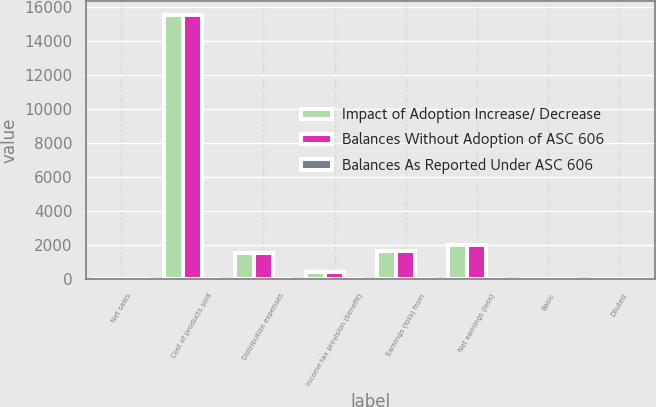<chart> <loc_0><loc_0><loc_500><loc_500><stacked_bar_chart><ecel><fcel>Net sales<fcel>Cost of products sold<fcel>Distribution expenses<fcel>Income tax provision (benefit)<fcel>Earnings (loss) from<fcel>Net earnings (loss)<fcel>Basic<fcel>Diluted<nl><fcel>Impact of Adoption Increase/ Decrease<fcel>26<fcel>15555<fcel>1567<fcel>445<fcel>1672<fcel>2017<fcel>4.91<fcel>4.85<nl><fcel>Balances Without Adoption of ASC 606<fcel>26<fcel>15535<fcel>1563<fcel>443<fcel>1666<fcel>2011<fcel>4.9<fcel>4.84<nl><fcel>Balances As Reported Under ASC 606<fcel>32<fcel>20<fcel>4<fcel>2<fcel>6<fcel>6<fcel>0.01<fcel>0.01<nl></chart> 